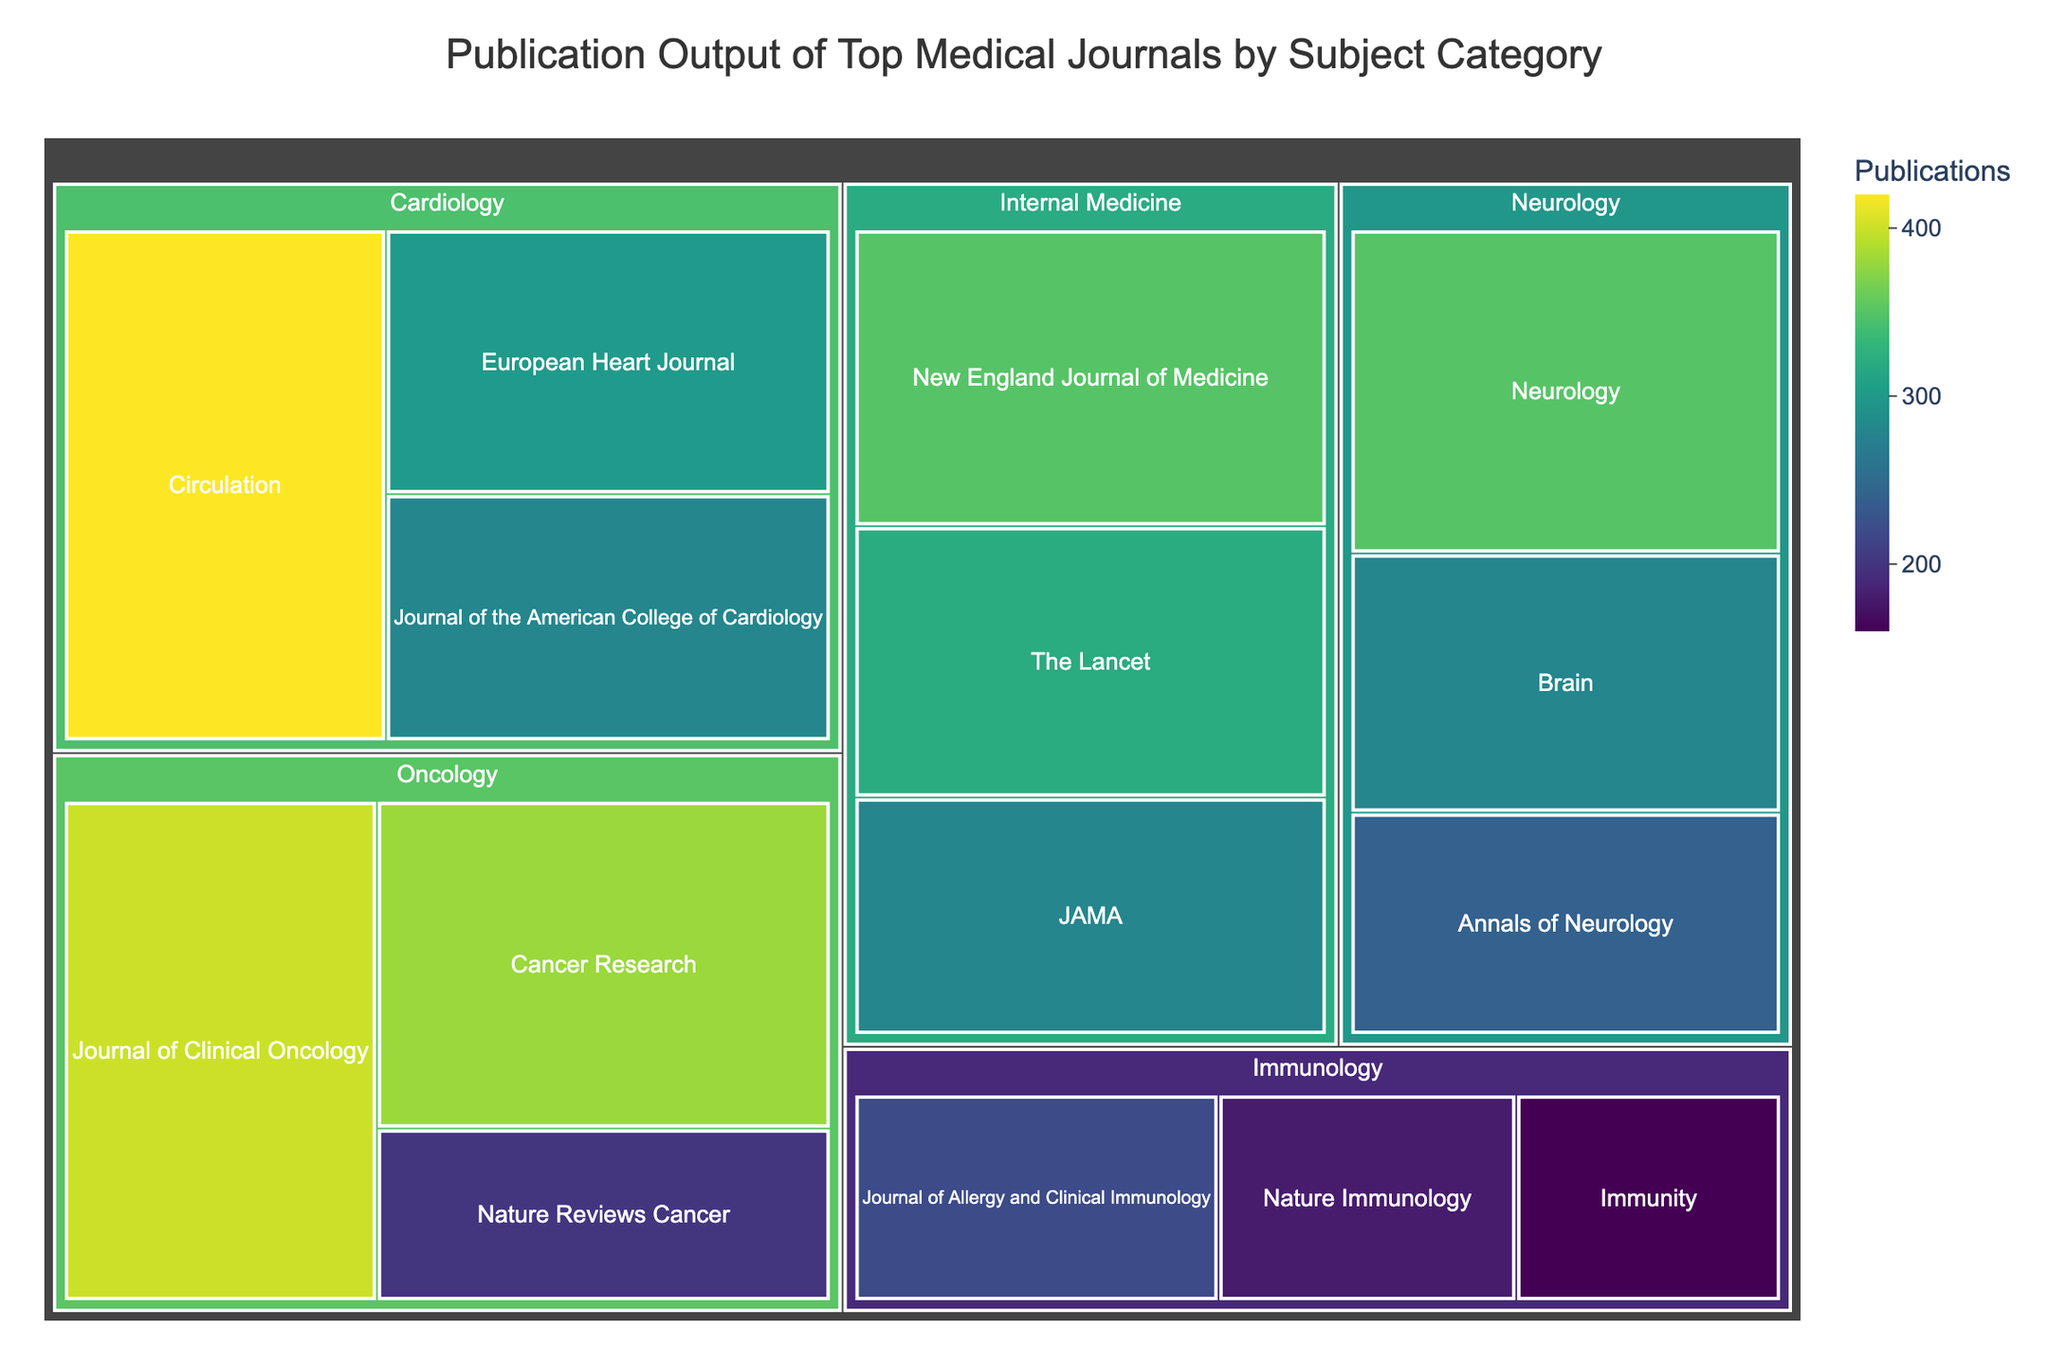what is the title of the treemap? The title is located at the top of the treemap and summarizes the main content and purpose of the chart.
Answer: Publication Output of Top Medical Journals by Subject Category Which journal has the most publications in the Cardiology category? Look at the tiles under 'Cardiology' and identify the one with the highest publication count. 'Circulation' has the most publications, which is 420.
Answer: Circulation How many journals are there in the Internal Medicine category? Count the distinct tiles under the 'Internal Medicine' category. There are 3 tiles representing three journals.
Answer: 3 What's the sum of publications for all Neurology journals? Add the publication counts for all journals under 'Neurology': 350 (Neurology) + 280 (Brain) + 240 (Annals of Neurology) = 870.
Answer: 870 Which category has the lowest publication count for its leading journal? Compare the publication counts of the leading journals—those with the highest count within each category. For Immunology (220), Neurology (350), Cardiology (420), Oncology (400), Internal Medicine (350). Immunology has the lowest count at 220 publications.
Answer: Immunology Is the Journal of the American College of Cardiology's publication count higher or lower than the Journal of Clinical Oncology's count? Compare the two specific publication counts: 280 (Journal of the American College of Cardiology) and 400 (Journal of Clinical Oncology). The former is lower.
Answer: Lower How does the total publication output of Oncology compare to that of Immunology? Sum the publication counts for each category then compare: Oncology (400 + 380 + 200 = 980) and Immunology (180 + 220 + 160 = 560). Oncology has a greater total.
Answer: Oncology has more What is the average publication count for journals in the Internal Medicine category? Sum the publication counts for Internal Medicine and divide by the total number of journals in that category: (350 + 320 + 280) / 3 = 950 / 3 ≈ 316.7.
Answer: Approximately 316.7 Which journal has the second-highest number of publications in the Oncology category? Identify the publications in Oncology and determine the second-highest after 400 (Journal of Clinical Oncology), which is 380 (Cancer Research).
Answer: Cancer Research 